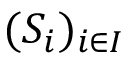Convert formula to latex. <formula><loc_0><loc_0><loc_500><loc_500>( S _ { i } ) _ { i \in I }</formula> 